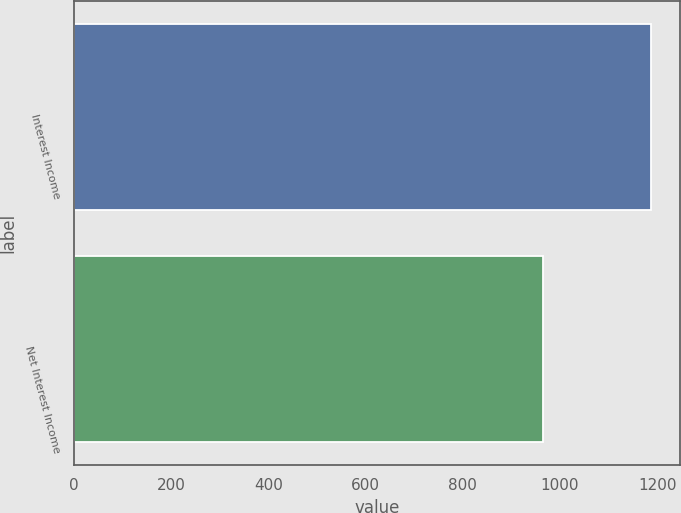Convert chart. <chart><loc_0><loc_0><loc_500><loc_500><bar_chart><fcel>Interest Income<fcel>Net Interest Income<nl><fcel>1188<fcel>965.6<nl></chart> 